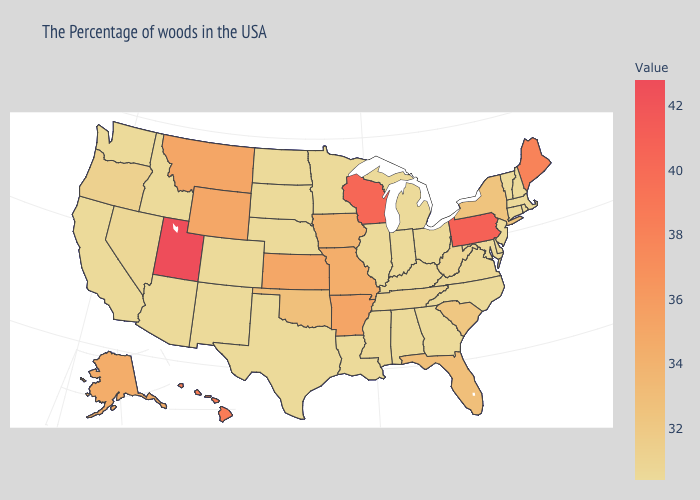Among the states that border Wisconsin , does Michigan have the highest value?
Short answer required. No. Among the states that border Kansas , which have the lowest value?
Give a very brief answer. Nebraska, Colorado. Does Nebraska have the highest value in the MidWest?
Give a very brief answer. No. Does Hawaii have the lowest value in the West?
Concise answer only. No. Among the states that border Oregon , which have the lowest value?
Short answer required. Idaho, California, Washington. Among the states that border Vermont , does New York have the lowest value?
Answer briefly. No. Among the states that border Montana , which have the lowest value?
Concise answer only. South Dakota, North Dakota, Idaho. 